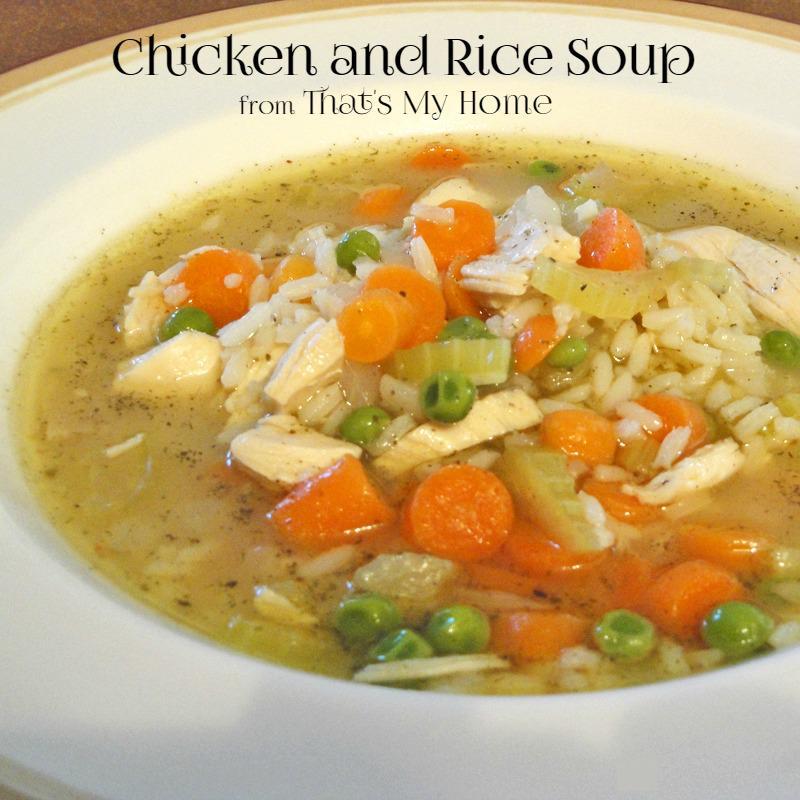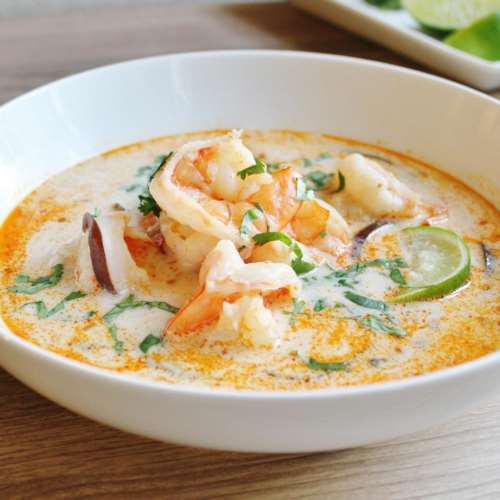The first image is the image on the left, the second image is the image on the right. Evaluate the accuracy of this statement regarding the images: "A spoon is in a white bowl of chicken soup with carrots, while a second image shows two or more bowls of a different chicken soup.". Is it true? Answer yes or no. No. The first image is the image on the left, the second image is the image on the right. For the images displayed, is the sentence "there is a spoon in the bowl of soup" factually correct? Answer yes or no. No. 